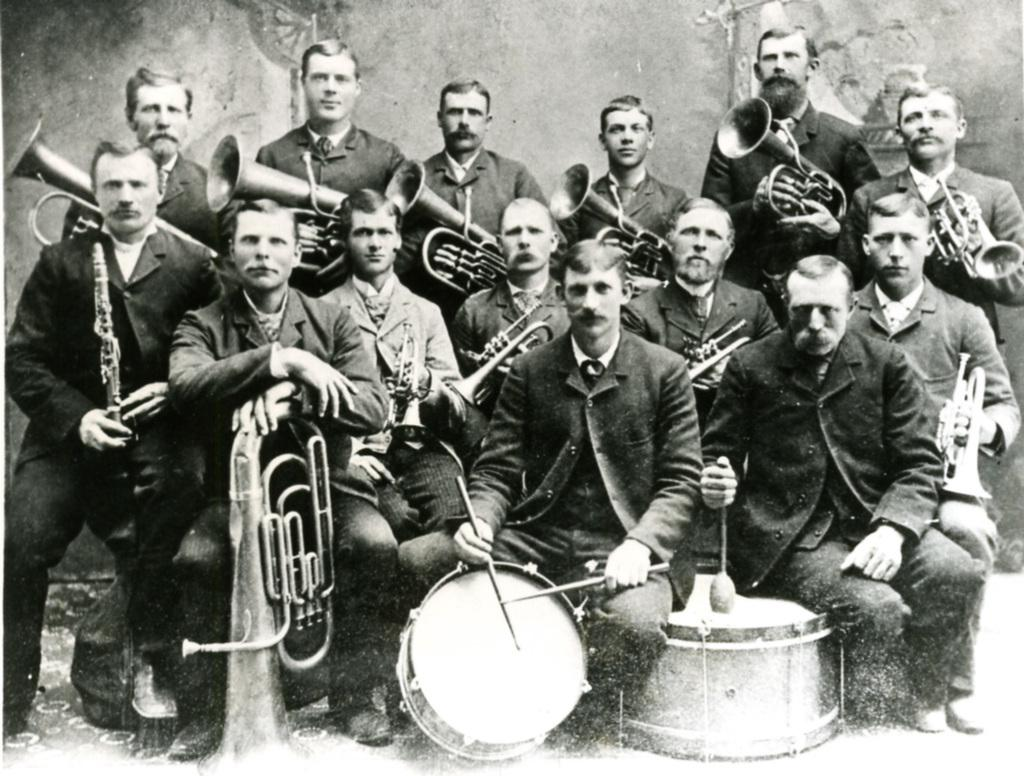What is the main subject of the image? The main subject of the image is a group of people. What are the people in the image doing? The group of people is holding musical instruments. What type of doctor is present in the image? There is no doctor present in the image; it features a group of people holding musical instruments. Is there a bridge visible in the image? There is no bridge present in the image. 